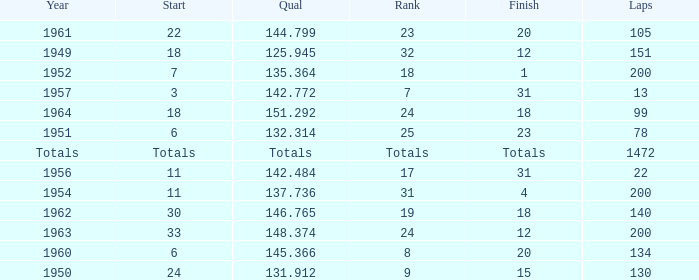Name the finish with Laps more than 200 Totals. 